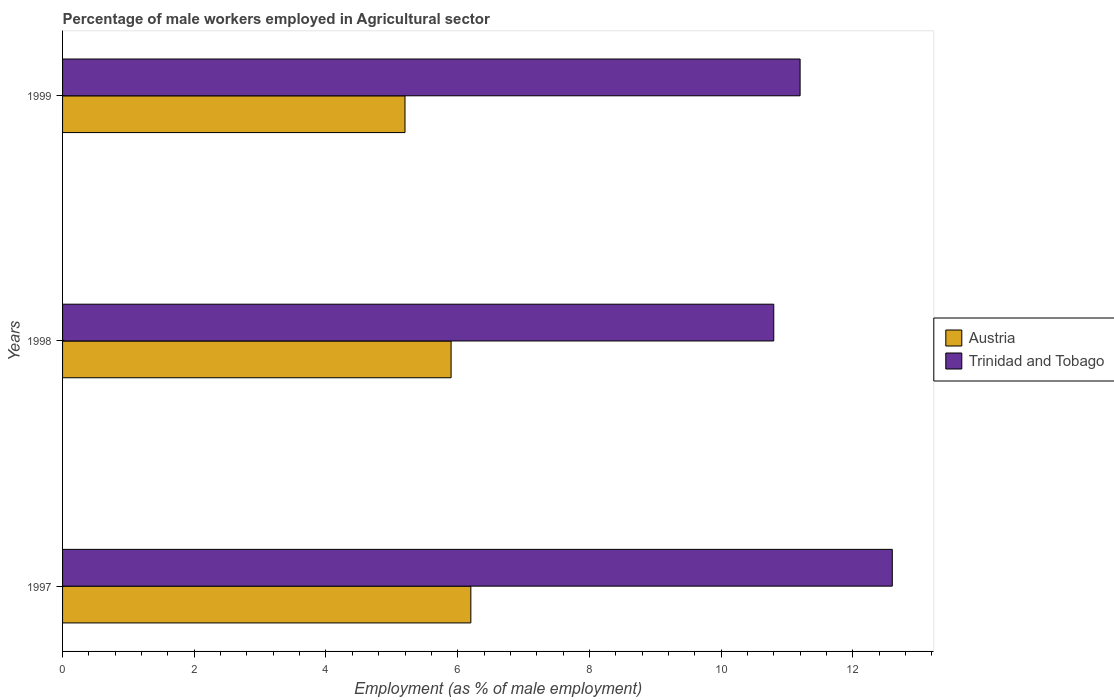How many different coloured bars are there?
Offer a terse response. 2. How many groups of bars are there?
Your response must be concise. 3. Are the number of bars on each tick of the Y-axis equal?
Make the answer very short. Yes. How many bars are there on the 2nd tick from the bottom?
Make the answer very short. 2. What is the label of the 2nd group of bars from the top?
Your answer should be compact. 1998. What is the percentage of male workers employed in Agricultural sector in Trinidad and Tobago in 1999?
Offer a terse response. 11.2. Across all years, what is the maximum percentage of male workers employed in Agricultural sector in Trinidad and Tobago?
Your answer should be very brief. 12.6. Across all years, what is the minimum percentage of male workers employed in Agricultural sector in Trinidad and Tobago?
Give a very brief answer. 10.8. In which year was the percentage of male workers employed in Agricultural sector in Austria maximum?
Make the answer very short. 1997. What is the total percentage of male workers employed in Agricultural sector in Trinidad and Tobago in the graph?
Ensure brevity in your answer.  34.6. What is the difference between the percentage of male workers employed in Agricultural sector in Austria in 1997 and that in 1998?
Ensure brevity in your answer.  0.3. What is the difference between the percentage of male workers employed in Agricultural sector in Austria in 1998 and the percentage of male workers employed in Agricultural sector in Trinidad and Tobago in 1999?
Your answer should be compact. -5.3. What is the average percentage of male workers employed in Agricultural sector in Austria per year?
Keep it short and to the point. 5.77. In the year 1997, what is the difference between the percentage of male workers employed in Agricultural sector in Austria and percentage of male workers employed in Agricultural sector in Trinidad and Tobago?
Provide a short and direct response. -6.4. What is the ratio of the percentage of male workers employed in Agricultural sector in Austria in 1998 to that in 1999?
Your answer should be very brief. 1.13. Is the percentage of male workers employed in Agricultural sector in Trinidad and Tobago in 1997 less than that in 1999?
Your answer should be compact. No. Is the difference between the percentage of male workers employed in Agricultural sector in Austria in 1998 and 1999 greater than the difference between the percentage of male workers employed in Agricultural sector in Trinidad and Tobago in 1998 and 1999?
Make the answer very short. Yes. What is the difference between the highest and the second highest percentage of male workers employed in Agricultural sector in Austria?
Give a very brief answer. 0.3. What is the difference between the highest and the lowest percentage of male workers employed in Agricultural sector in Austria?
Provide a succinct answer. 1. What does the 1st bar from the top in 1997 represents?
Your answer should be very brief. Trinidad and Tobago. What does the 2nd bar from the bottom in 1998 represents?
Your answer should be compact. Trinidad and Tobago. Are all the bars in the graph horizontal?
Your response must be concise. Yes. How many years are there in the graph?
Ensure brevity in your answer.  3. What is the difference between two consecutive major ticks on the X-axis?
Provide a succinct answer. 2. Are the values on the major ticks of X-axis written in scientific E-notation?
Keep it short and to the point. No. Where does the legend appear in the graph?
Your answer should be very brief. Center right. How many legend labels are there?
Offer a terse response. 2. How are the legend labels stacked?
Make the answer very short. Vertical. What is the title of the graph?
Offer a very short reply. Percentage of male workers employed in Agricultural sector. What is the label or title of the X-axis?
Keep it short and to the point. Employment (as % of male employment). What is the Employment (as % of male employment) in Austria in 1997?
Offer a very short reply. 6.2. What is the Employment (as % of male employment) of Trinidad and Tobago in 1997?
Ensure brevity in your answer.  12.6. What is the Employment (as % of male employment) of Austria in 1998?
Offer a terse response. 5.9. What is the Employment (as % of male employment) of Trinidad and Tobago in 1998?
Offer a terse response. 10.8. What is the Employment (as % of male employment) of Austria in 1999?
Provide a succinct answer. 5.2. What is the Employment (as % of male employment) of Trinidad and Tobago in 1999?
Give a very brief answer. 11.2. Across all years, what is the maximum Employment (as % of male employment) in Austria?
Offer a terse response. 6.2. Across all years, what is the maximum Employment (as % of male employment) in Trinidad and Tobago?
Provide a succinct answer. 12.6. Across all years, what is the minimum Employment (as % of male employment) in Austria?
Ensure brevity in your answer.  5.2. Across all years, what is the minimum Employment (as % of male employment) of Trinidad and Tobago?
Ensure brevity in your answer.  10.8. What is the total Employment (as % of male employment) of Austria in the graph?
Make the answer very short. 17.3. What is the total Employment (as % of male employment) in Trinidad and Tobago in the graph?
Provide a succinct answer. 34.6. What is the difference between the Employment (as % of male employment) in Trinidad and Tobago in 1997 and that in 1998?
Offer a very short reply. 1.8. What is the difference between the Employment (as % of male employment) in Austria in 1998 and that in 1999?
Ensure brevity in your answer.  0.7. What is the average Employment (as % of male employment) in Austria per year?
Offer a terse response. 5.77. What is the average Employment (as % of male employment) of Trinidad and Tobago per year?
Keep it short and to the point. 11.53. In the year 1998, what is the difference between the Employment (as % of male employment) of Austria and Employment (as % of male employment) of Trinidad and Tobago?
Provide a succinct answer. -4.9. In the year 1999, what is the difference between the Employment (as % of male employment) of Austria and Employment (as % of male employment) of Trinidad and Tobago?
Make the answer very short. -6. What is the ratio of the Employment (as % of male employment) in Austria in 1997 to that in 1998?
Your response must be concise. 1.05. What is the ratio of the Employment (as % of male employment) of Trinidad and Tobago in 1997 to that in 1998?
Offer a very short reply. 1.17. What is the ratio of the Employment (as % of male employment) of Austria in 1997 to that in 1999?
Keep it short and to the point. 1.19. What is the ratio of the Employment (as % of male employment) in Austria in 1998 to that in 1999?
Offer a terse response. 1.13. What is the ratio of the Employment (as % of male employment) in Trinidad and Tobago in 1998 to that in 1999?
Make the answer very short. 0.96. What is the difference between the highest and the second highest Employment (as % of male employment) in Austria?
Offer a very short reply. 0.3. What is the difference between the highest and the second highest Employment (as % of male employment) in Trinidad and Tobago?
Your answer should be very brief. 1.4. 